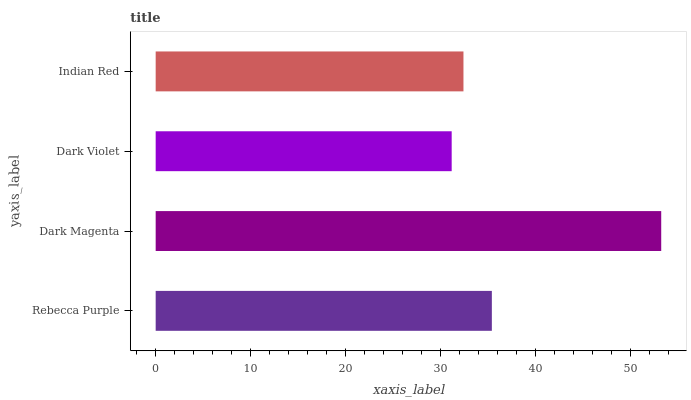Is Dark Violet the minimum?
Answer yes or no. Yes. Is Dark Magenta the maximum?
Answer yes or no. Yes. Is Dark Magenta the minimum?
Answer yes or no. No. Is Dark Violet the maximum?
Answer yes or no. No. Is Dark Magenta greater than Dark Violet?
Answer yes or no. Yes. Is Dark Violet less than Dark Magenta?
Answer yes or no. Yes. Is Dark Violet greater than Dark Magenta?
Answer yes or no. No. Is Dark Magenta less than Dark Violet?
Answer yes or no. No. Is Rebecca Purple the high median?
Answer yes or no. Yes. Is Indian Red the low median?
Answer yes or no. Yes. Is Indian Red the high median?
Answer yes or no. No. Is Dark Magenta the low median?
Answer yes or no. No. 